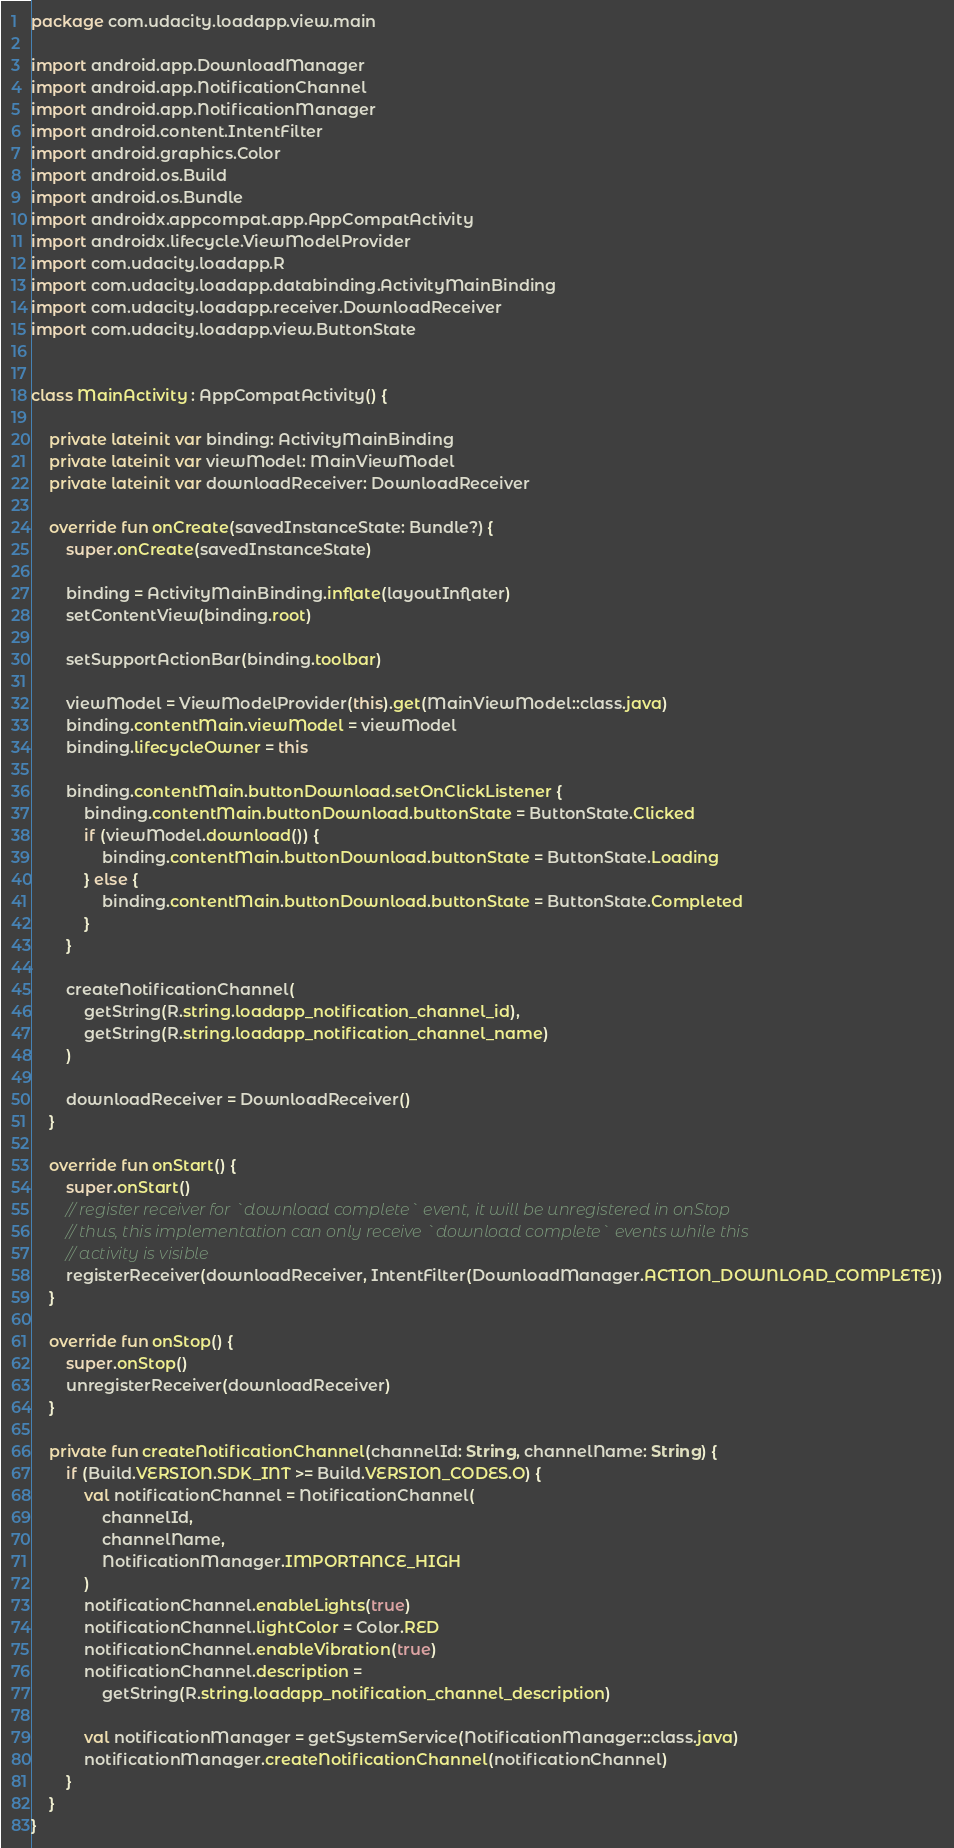Convert code to text. <code><loc_0><loc_0><loc_500><loc_500><_Kotlin_>package com.udacity.loadapp.view.main

import android.app.DownloadManager
import android.app.NotificationChannel
import android.app.NotificationManager
import android.content.IntentFilter
import android.graphics.Color
import android.os.Build
import android.os.Bundle
import androidx.appcompat.app.AppCompatActivity
import androidx.lifecycle.ViewModelProvider
import com.udacity.loadapp.R
import com.udacity.loadapp.databinding.ActivityMainBinding
import com.udacity.loadapp.receiver.DownloadReceiver
import com.udacity.loadapp.view.ButtonState


class MainActivity : AppCompatActivity() {

    private lateinit var binding: ActivityMainBinding
    private lateinit var viewModel: MainViewModel
    private lateinit var downloadReceiver: DownloadReceiver

    override fun onCreate(savedInstanceState: Bundle?) {
        super.onCreate(savedInstanceState)

        binding = ActivityMainBinding.inflate(layoutInflater)
        setContentView(binding.root)

        setSupportActionBar(binding.toolbar)

        viewModel = ViewModelProvider(this).get(MainViewModel::class.java)
        binding.contentMain.viewModel = viewModel
        binding.lifecycleOwner = this

        binding.contentMain.buttonDownload.setOnClickListener {
            binding.contentMain.buttonDownload.buttonState = ButtonState.Clicked
            if (viewModel.download()) {
                binding.contentMain.buttonDownload.buttonState = ButtonState.Loading
            } else {
                binding.contentMain.buttonDownload.buttonState = ButtonState.Completed
            }
        }

        createNotificationChannel(
            getString(R.string.loadapp_notification_channel_id),
            getString(R.string.loadapp_notification_channel_name)
        )

        downloadReceiver = DownloadReceiver()
    }

    override fun onStart() {
        super.onStart()
        // register receiver for `download complete` event, it will be unregistered in onStop
        // thus, this implementation can only receive `download complete` events while this
        // activity is visible
        registerReceiver(downloadReceiver, IntentFilter(DownloadManager.ACTION_DOWNLOAD_COMPLETE))
    }

    override fun onStop() {
        super.onStop()
        unregisterReceiver(downloadReceiver)
    }

    private fun createNotificationChannel(channelId: String, channelName: String) {
        if (Build.VERSION.SDK_INT >= Build.VERSION_CODES.O) {
            val notificationChannel = NotificationChannel(
                channelId,
                channelName,
                NotificationManager.IMPORTANCE_HIGH
            )
            notificationChannel.enableLights(true)
            notificationChannel.lightColor = Color.RED
            notificationChannel.enableVibration(true)
            notificationChannel.description =
                getString(R.string.loadapp_notification_channel_description)

            val notificationManager = getSystemService(NotificationManager::class.java)
            notificationManager.createNotificationChannel(notificationChannel)
        }
    }
}
</code> 